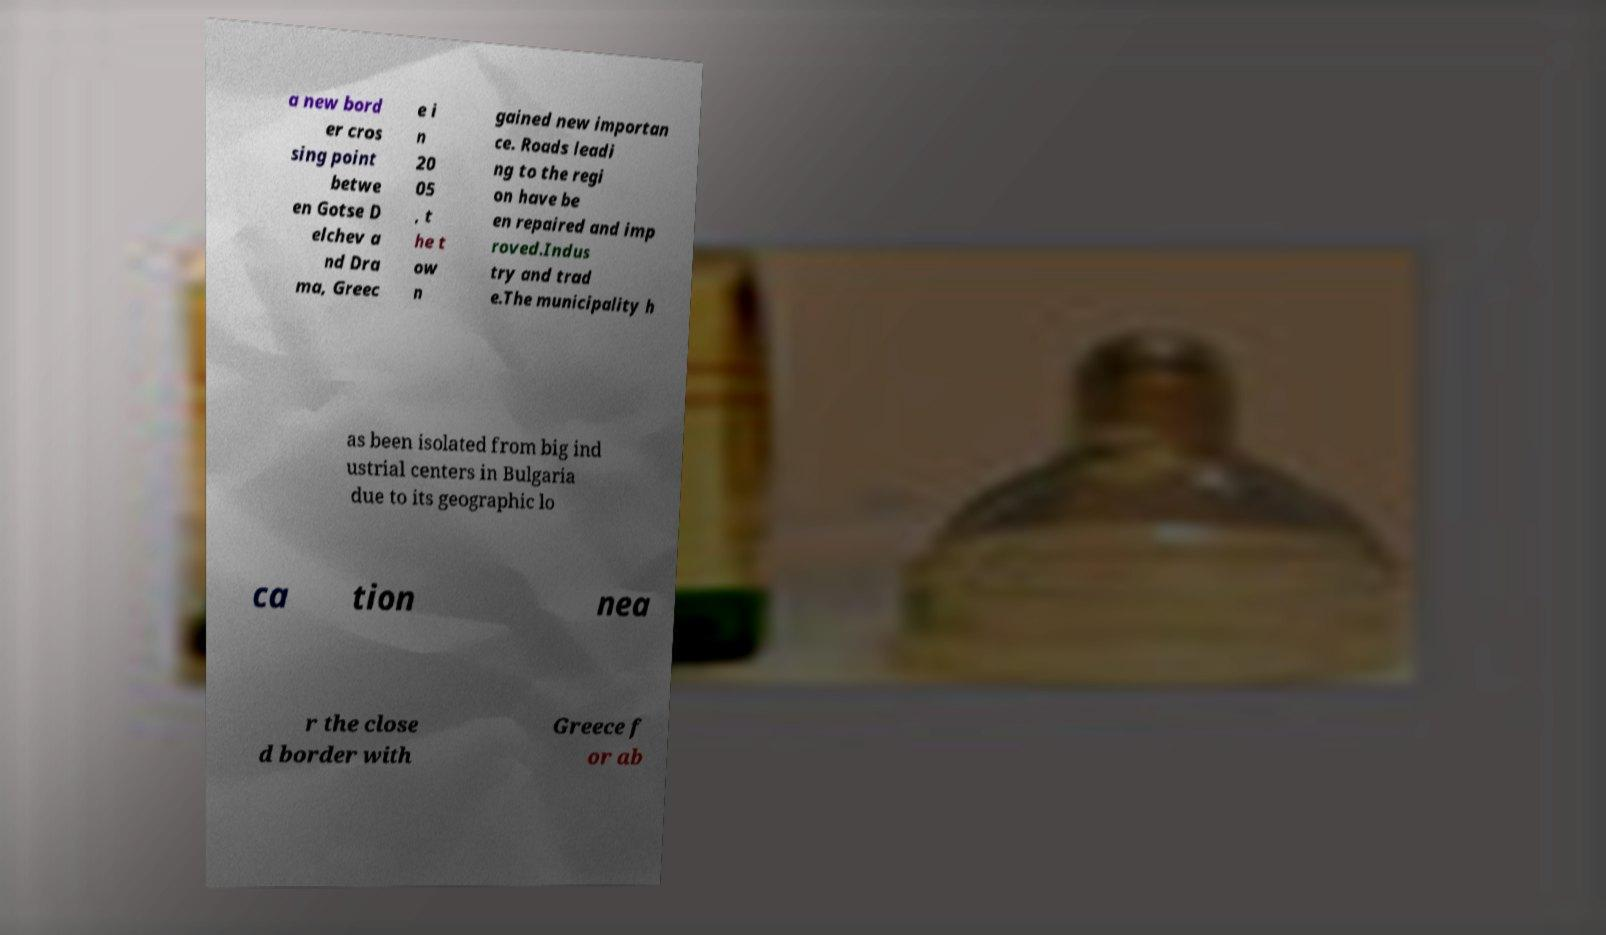Could you extract and type out the text from this image? a new bord er cros sing point betwe en Gotse D elchev a nd Dra ma, Greec e i n 20 05 , t he t ow n gained new importan ce. Roads leadi ng to the regi on have be en repaired and imp roved.Indus try and trad e.The municipality h as been isolated from big ind ustrial centers in Bulgaria due to its geographic lo ca tion nea r the close d border with Greece f or ab 